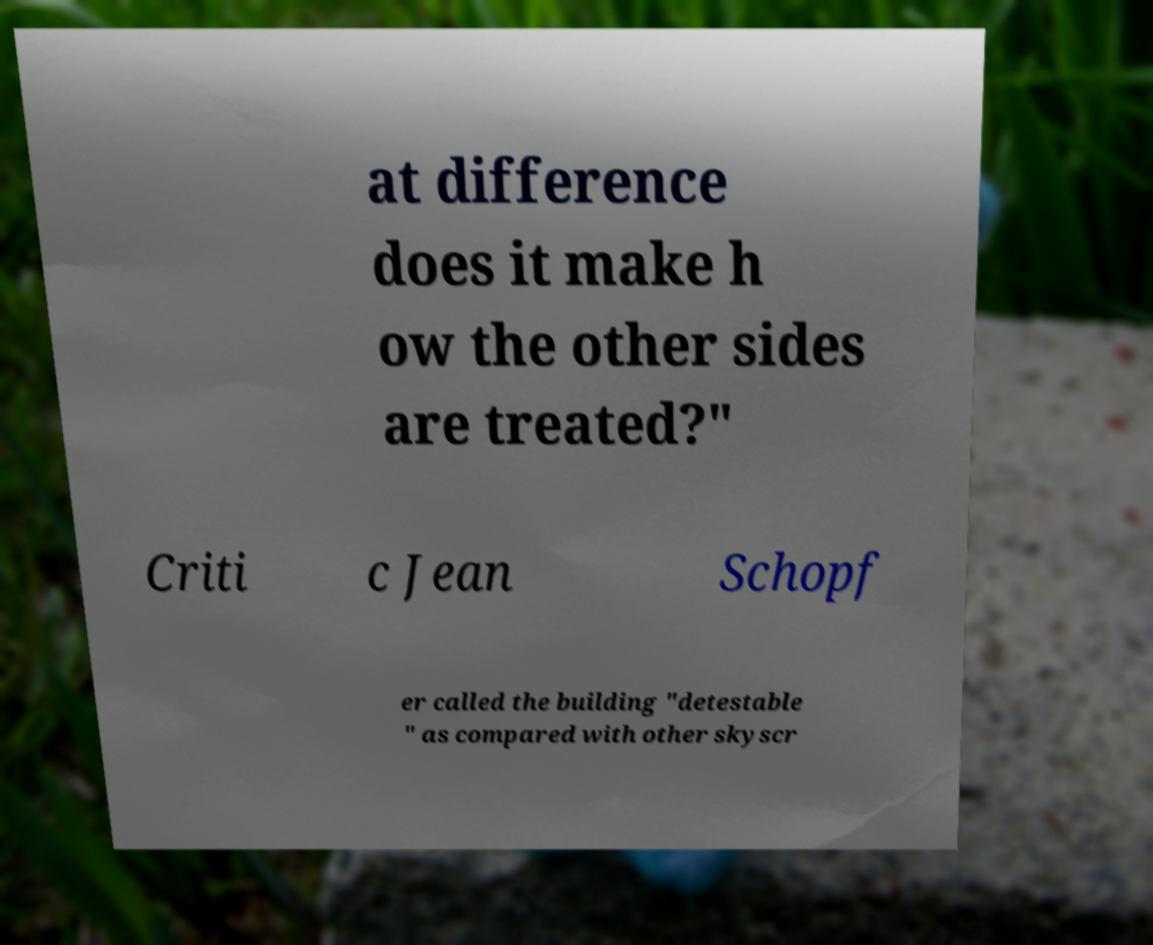Can you accurately transcribe the text from the provided image for me? at difference does it make h ow the other sides are treated?" Criti c Jean Schopf er called the building "detestable " as compared with other skyscr 